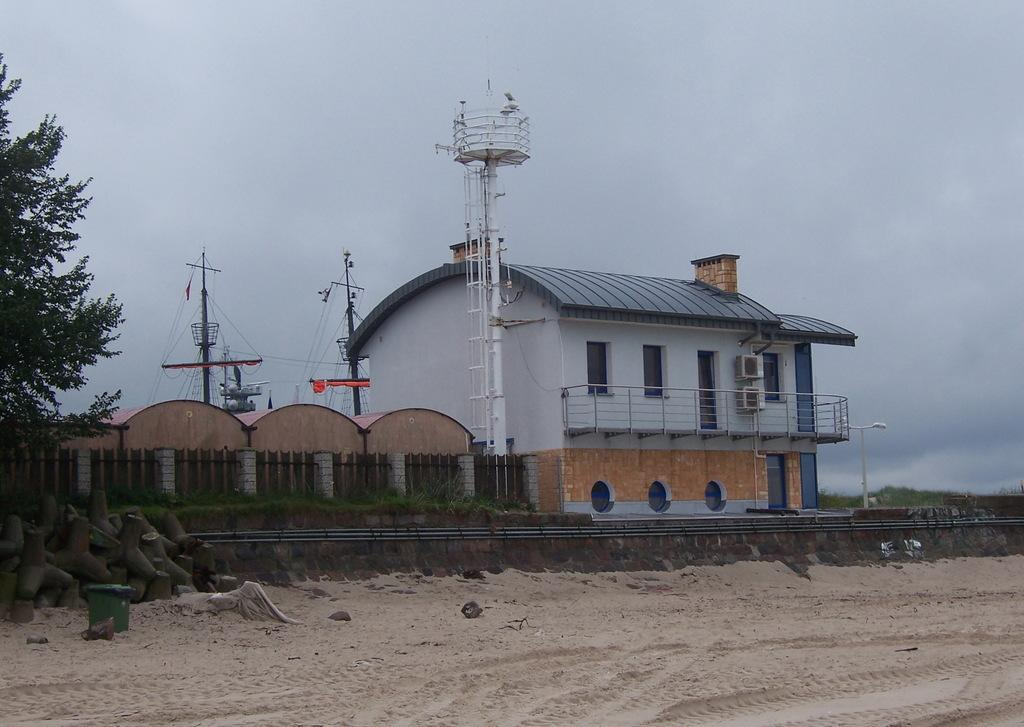What is the main subject in the middle of the image? There is a house in the middle of the image. What is the color of the house? The house is white. What type of vegetation is on the left side of the image? There are trees on the left side of the image. What is visible at the top of the image? The sky is visible at the top of the image. Can you see the wall being bitten by the self in the image? There is no wall or self present in the image, and therefore no such activity can be observed. 